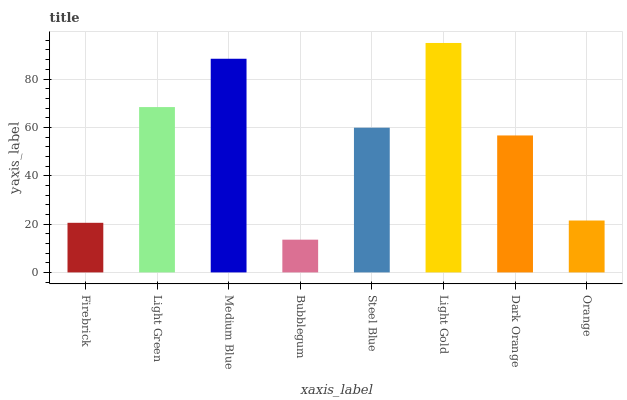Is Bubblegum the minimum?
Answer yes or no. Yes. Is Light Gold the maximum?
Answer yes or no. Yes. Is Light Green the minimum?
Answer yes or no. No. Is Light Green the maximum?
Answer yes or no. No. Is Light Green greater than Firebrick?
Answer yes or no. Yes. Is Firebrick less than Light Green?
Answer yes or no. Yes. Is Firebrick greater than Light Green?
Answer yes or no. No. Is Light Green less than Firebrick?
Answer yes or no. No. Is Steel Blue the high median?
Answer yes or no. Yes. Is Dark Orange the low median?
Answer yes or no. Yes. Is Bubblegum the high median?
Answer yes or no. No. Is Medium Blue the low median?
Answer yes or no. No. 